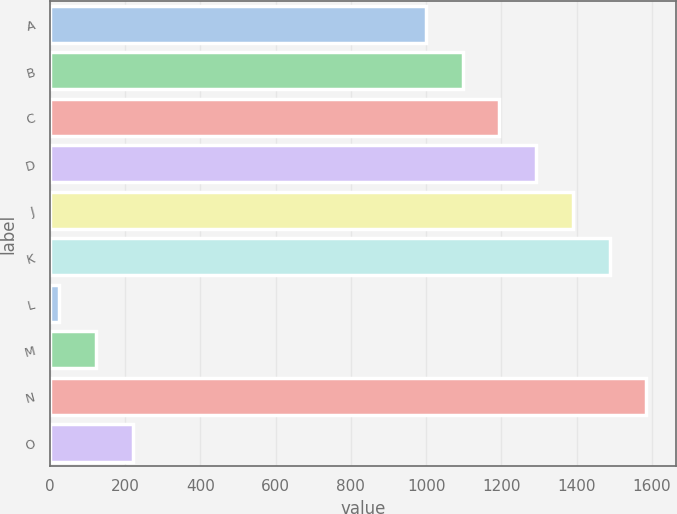<chart> <loc_0><loc_0><loc_500><loc_500><bar_chart><fcel>A<fcel>B<fcel>C<fcel>D<fcel>J<fcel>K<fcel>L<fcel>M<fcel>N<fcel>O<nl><fcel>1000<fcel>1097.5<fcel>1195<fcel>1292.5<fcel>1390<fcel>1487.5<fcel>25<fcel>122.5<fcel>1585<fcel>220<nl></chart> 